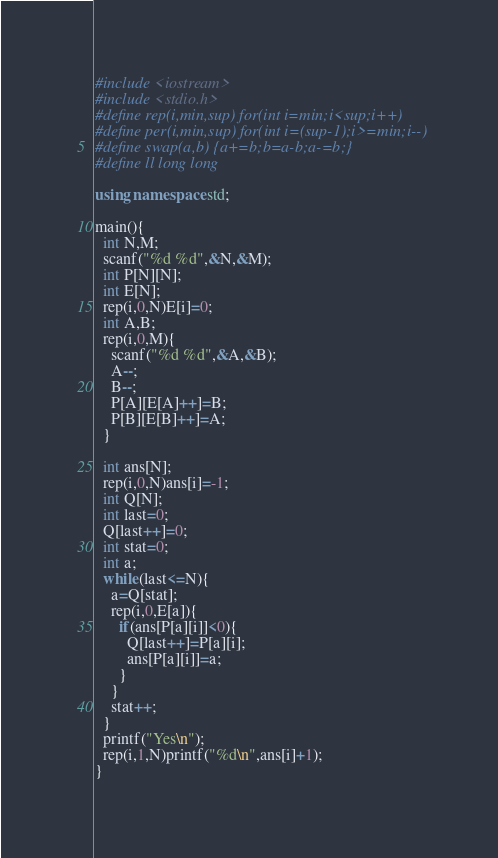<code> <loc_0><loc_0><loc_500><loc_500><_C++_>#include <iostream>
#include <stdio.h>
#define rep(i,min,sup) for(int i=min;i<sup;i++)
#define per(i,min,sup) for(int i=(sup-1);i>=min;i--)
#define swap(a,b) {a+=b;b=a-b;a-=b;}
#define ll long long

using namespace std;
 
main(){
  int N,M;
  scanf("%d %d",&N,&M);
  int P[N][N];
  int E[N];
  rep(i,0,N)E[i]=0;
  int A,B;
  rep(i,0,M){
    scanf("%d %d",&A,&B);
    A--;
    B--;
    P[A][E[A]++]=B;
    P[B][E[B]++]=A;
  }
  
  int ans[N];
  rep(i,0,N)ans[i]=-1;
  int Q[N];
  int last=0;
  Q[last++]=0;
  int stat=0;
  int a;
  while(last<=N){
    a=Q[stat];
    rep(i,0,E[a]){
      if(ans[P[a][i]]<0){
        Q[last++]=P[a][i];
        ans[P[a][i]]=a;
      }
    }
    stat++;
  }
  printf("Yes\n");
  rep(i,1,N)printf("%d\n",ans[i]+1);
}</code> 